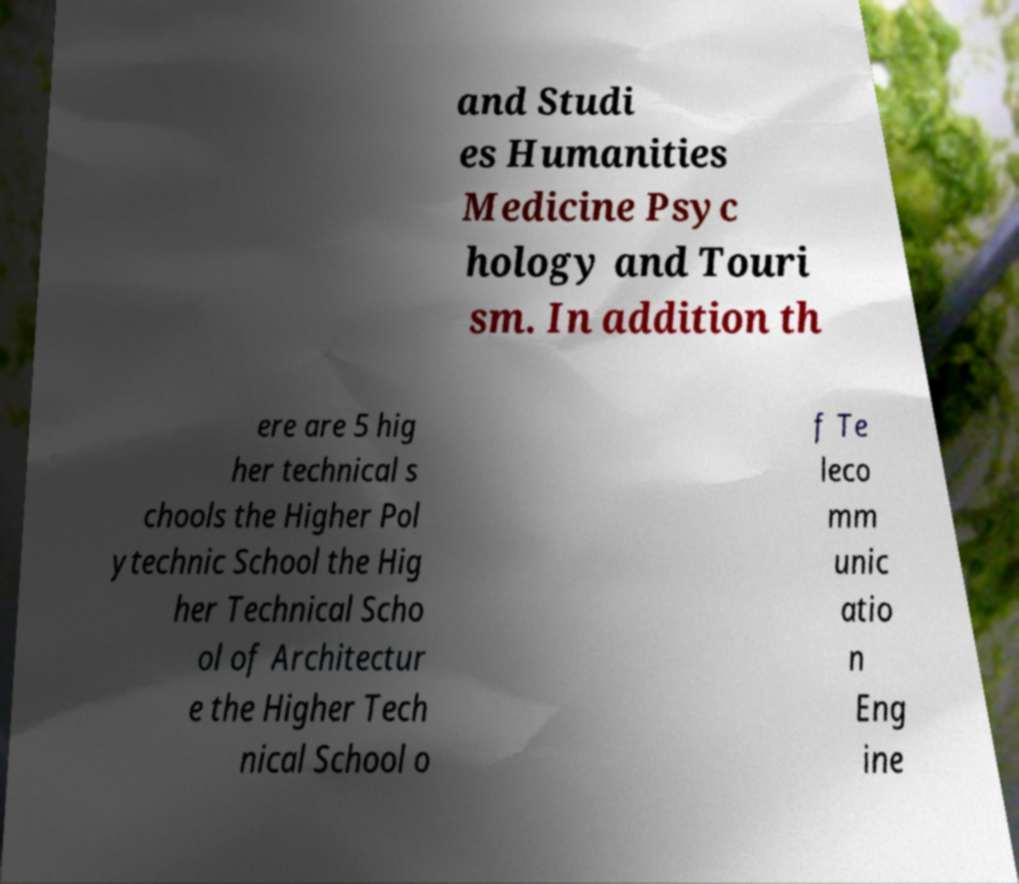Could you extract and type out the text from this image? and Studi es Humanities Medicine Psyc hology and Touri sm. In addition th ere are 5 hig her technical s chools the Higher Pol ytechnic School the Hig her Technical Scho ol of Architectur e the Higher Tech nical School o f Te leco mm unic atio n Eng ine 